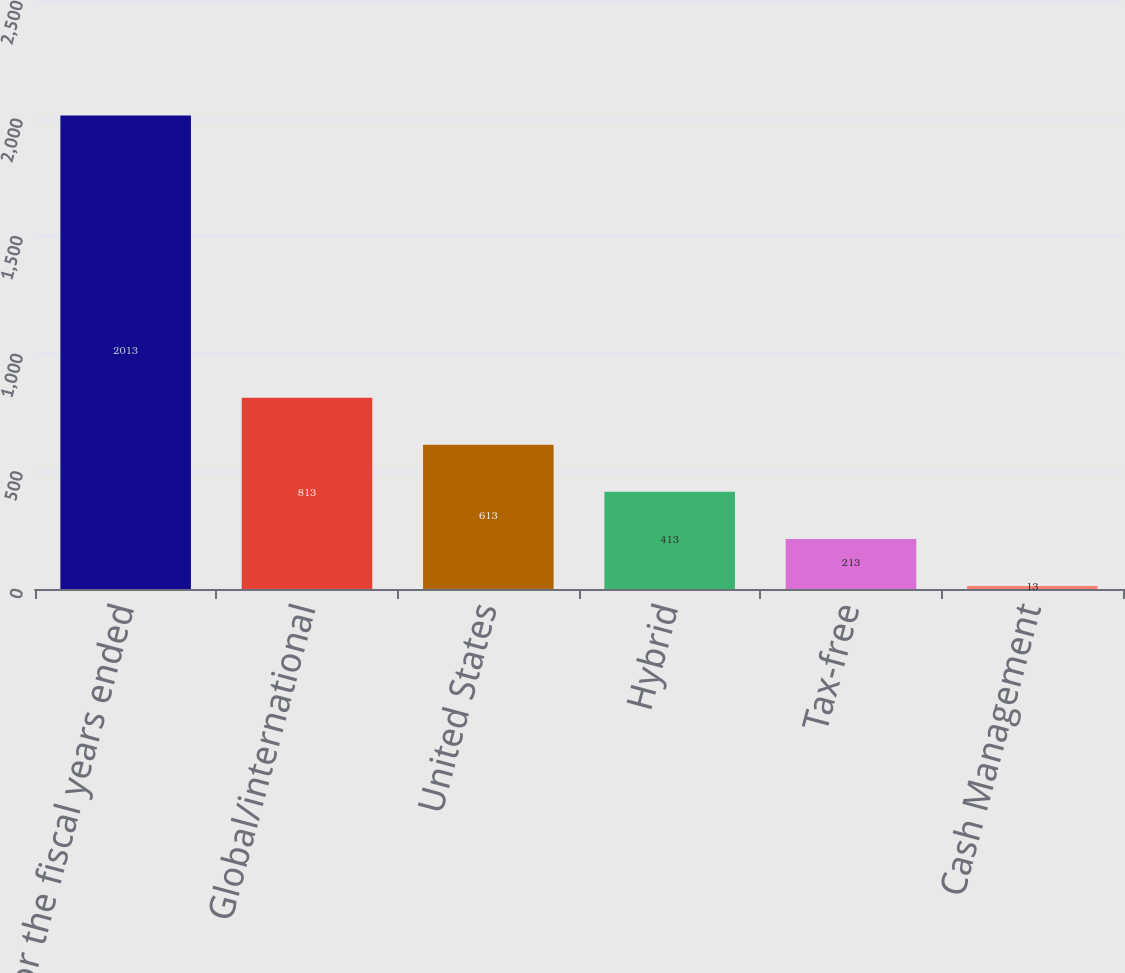Convert chart. <chart><loc_0><loc_0><loc_500><loc_500><bar_chart><fcel>for the fiscal years ended<fcel>Global/international<fcel>United States<fcel>Hybrid<fcel>Tax-free<fcel>Cash Management<nl><fcel>2013<fcel>813<fcel>613<fcel>413<fcel>213<fcel>13<nl></chart> 